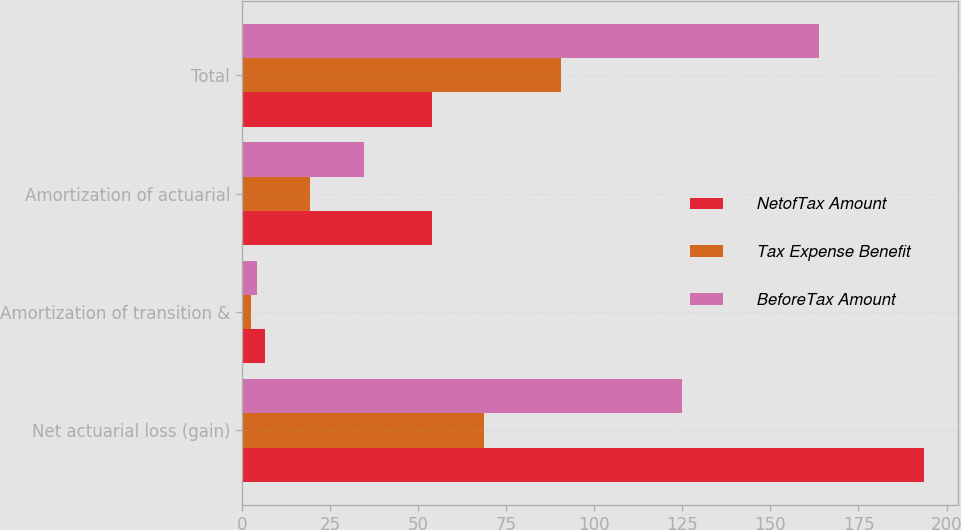Convert chart. <chart><loc_0><loc_0><loc_500><loc_500><stacked_bar_chart><ecel><fcel>Net actuarial loss (gain)<fcel>Amortization of transition &<fcel>Amortization of actuarial<fcel>Total<nl><fcel>NetofTax Amount<fcel>193.7<fcel>6.7<fcel>54<fcel>54<nl><fcel>Tax Expense Benefit<fcel>68.7<fcel>2.5<fcel>19.3<fcel>90.5<nl><fcel>BeforeTax Amount<fcel>125<fcel>4.2<fcel>34.7<fcel>163.9<nl></chart> 